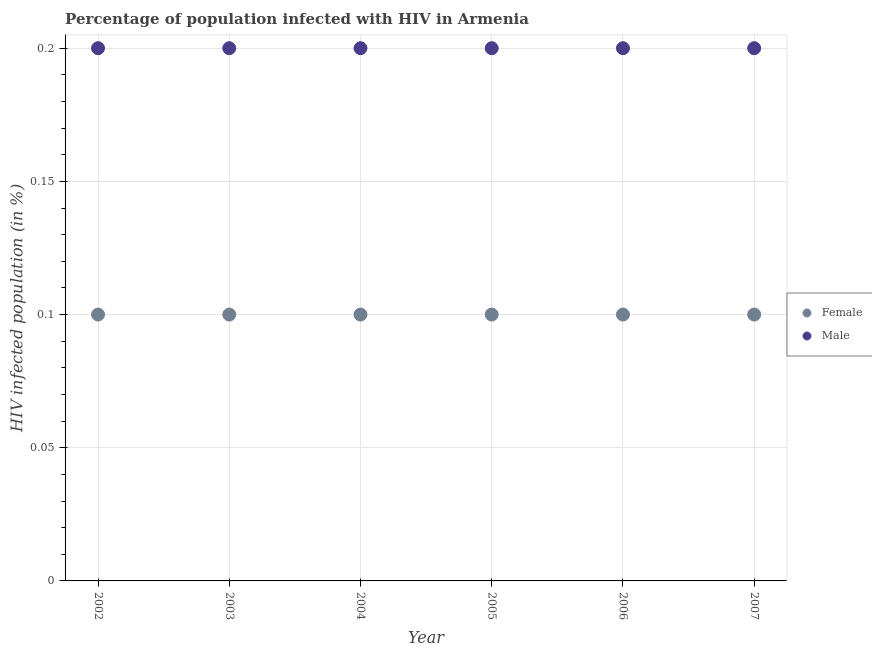How many different coloured dotlines are there?
Give a very brief answer. 2. Is the number of dotlines equal to the number of legend labels?
Keep it short and to the point. Yes. Across all years, what is the maximum percentage of males who are infected with hiv?
Keep it short and to the point. 0.2. What is the total percentage of females who are infected with hiv in the graph?
Offer a very short reply. 0.6. What is the average percentage of males who are infected with hiv per year?
Your answer should be very brief. 0.2. In how many years, is the percentage of males who are infected with hiv greater than 0.03 %?
Make the answer very short. 6. What is the ratio of the percentage of females who are infected with hiv in 2002 to that in 2004?
Ensure brevity in your answer.  1. Is the percentage of females who are infected with hiv in 2004 less than that in 2007?
Your answer should be compact. No. Is the difference between the percentage of males who are infected with hiv in 2005 and 2006 greater than the difference between the percentage of females who are infected with hiv in 2005 and 2006?
Your answer should be very brief. No. In how many years, is the percentage of females who are infected with hiv greater than the average percentage of females who are infected with hiv taken over all years?
Offer a terse response. 6. Is the sum of the percentage of females who are infected with hiv in 2005 and 2007 greater than the maximum percentage of males who are infected with hiv across all years?
Ensure brevity in your answer.  No. Does the percentage of females who are infected with hiv monotonically increase over the years?
Your answer should be compact. No. Is the percentage of males who are infected with hiv strictly greater than the percentage of females who are infected with hiv over the years?
Provide a short and direct response. Yes. Is the percentage of females who are infected with hiv strictly less than the percentage of males who are infected with hiv over the years?
Make the answer very short. Yes. How many dotlines are there?
Make the answer very short. 2. What is the difference between two consecutive major ticks on the Y-axis?
Make the answer very short. 0.05. Are the values on the major ticks of Y-axis written in scientific E-notation?
Offer a terse response. No. Does the graph contain grids?
Offer a terse response. Yes. How many legend labels are there?
Keep it short and to the point. 2. What is the title of the graph?
Keep it short and to the point. Percentage of population infected with HIV in Armenia. Does "Commercial service imports" appear as one of the legend labels in the graph?
Offer a terse response. No. What is the label or title of the Y-axis?
Your answer should be compact. HIV infected population (in %). What is the HIV infected population (in %) in Female in 2002?
Provide a succinct answer. 0.1. What is the HIV infected population (in %) in Male in 2003?
Your answer should be compact. 0.2. What is the HIV infected population (in %) of Male in 2005?
Your answer should be compact. 0.2. What is the HIV infected population (in %) in Male in 2006?
Your answer should be very brief. 0.2. What is the HIV infected population (in %) of Female in 2007?
Your answer should be very brief. 0.1. What is the HIV infected population (in %) of Male in 2007?
Your answer should be compact. 0.2. What is the total HIV infected population (in %) in Female in the graph?
Provide a short and direct response. 0.6. What is the total HIV infected population (in %) in Male in the graph?
Offer a very short reply. 1.2. What is the difference between the HIV infected population (in %) of Female in 2002 and that in 2005?
Your answer should be compact. 0. What is the difference between the HIV infected population (in %) in Female in 2002 and that in 2006?
Your answer should be compact. 0. What is the difference between the HIV infected population (in %) in Male in 2002 and that in 2006?
Your answer should be compact. 0. What is the difference between the HIV infected population (in %) in Female in 2002 and that in 2007?
Your answer should be compact. 0. What is the difference between the HIV infected population (in %) in Male in 2003 and that in 2004?
Offer a very short reply. 0. What is the difference between the HIV infected population (in %) in Female in 2003 and that in 2005?
Offer a very short reply. 0. What is the difference between the HIV infected population (in %) in Female in 2003 and that in 2007?
Ensure brevity in your answer.  0. What is the difference between the HIV infected population (in %) of Male in 2003 and that in 2007?
Ensure brevity in your answer.  0. What is the difference between the HIV infected population (in %) in Male in 2004 and that in 2005?
Offer a very short reply. 0. What is the difference between the HIV infected population (in %) in Female in 2005 and that in 2006?
Offer a terse response. 0. What is the difference between the HIV infected population (in %) in Male in 2005 and that in 2007?
Provide a short and direct response. 0. What is the difference between the HIV infected population (in %) in Male in 2006 and that in 2007?
Provide a succinct answer. 0. What is the difference between the HIV infected population (in %) in Female in 2002 and the HIV infected population (in %) in Male in 2003?
Your response must be concise. -0.1. What is the difference between the HIV infected population (in %) in Female in 2002 and the HIV infected population (in %) in Male in 2004?
Give a very brief answer. -0.1. What is the difference between the HIV infected population (in %) in Female in 2002 and the HIV infected population (in %) in Male in 2005?
Your response must be concise. -0.1. What is the difference between the HIV infected population (in %) in Female in 2002 and the HIV infected population (in %) in Male in 2007?
Ensure brevity in your answer.  -0.1. What is the difference between the HIV infected population (in %) of Female in 2003 and the HIV infected population (in %) of Male in 2006?
Make the answer very short. -0.1. What is the difference between the HIV infected population (in %) of Female in 2004 and the HIV infected population (in %) of Male in 2007?
Provide a succinct answer. -0.1. What is the difference between the HIV infected population (in %) of Female in 2005 and the HIV infected population (in %) of Male in 2006?
Your response must be concise. -0.1. What is the difference between the HIV infected population (in %) of Female in 2005 and the HIV infected population (in %) of Male in 2007?
Make the answer very short. -0.1. What is the average HIV infected population (in %) in Male per year?
Make the answer very short. 0.2. In the year 2003, what is the difference between the HIV infected population (in %) of Female and HIV infected population (in %) of Male?
Ensure brevity in your answer.  -0.1. In the year 2006, what is the difference between the HIV infected population (in %) of Female and HIV infected population (in %) of Male?
Offer a very short reply. -0.1. In the year 2007, what is the difference between the HIV infected population (in %) in Female and HIV infected population (in %) in Male?
Offer a very short reply. -0.1. What is the ratio of the HIV infected population (in %) of Female in 2002 to that in 2003?
Make the answer very short. 1. What is the ratio of the HIV infected population (in %) of Male in 2002 to that in 2003?
Your response must be concise. 1. What is the ratio of the HIV infected population (in %) of Male in 2002 to that in 2004?
Ensure brevity in your answer.  1. What is the ratio of the HIV infected population (in %) of Female in 2002 to that in 2006?
Make the answer very short. 1. What is the ratio of the HIV infected population (in %) in Female in 2003 to that in 2004?
Provide a succinct answer. 1. What is the ratio of the HIV infected population (in %) in Female in 2003 to that in 2005?
Offer a terse response. 1. What is the ratio of the HIV infected population (in %) of Female in 2003 to that in 2006?
Ensure brevity in your answer.  1. What is the ratio of the HIV infected population (in %) in Female in 2003 to that in 2007?
Provide a succinct answer. 1. What is the ratio of the HIV infected population (in %) in Male in 2003 to that in 2007?
Provide a short and direct response. 1. What is the ratio of the HIV infected population (in %) in Male in 2004 to that in 2005?
Provide a short and direct response. 1. What is the ratio of the HIV infected population (in %) in Male in 2004 to that in 2006?
Provide a succinct answer. 1. What is the ratio of the HIV infected population (in %) in Female in 2004 to that in 2007?
Provide a short and direct response. 1. What is the ratio of the HIV infected population (in %) in Male in 2004 to that in 2007?
Make the answer very short. 1. What is the ratio of the HIV infected population (in %) in Female in 2005 to that in 2006?
Provide a short and direct response. 1. What is the ratio of the HIV infected population (in %) in Male in 2005 to that in 2006?
Your answer should be very brief. 1. What is the ratio of the HIV infected population (in %) of Female in 2005 to that in 2007?
Give a very brief answer. 1. What is the ratio of the HIV infected population (in %) in Female in 2006 to that in 2007?
Ensure brevity in your answer.  1. What is the ratio of the HIV infected population (in %) of Male in 2006 to that in 2007?
Give a very brief answer. 1. What is the difference between the highest and the second highest HIV infected population (in %) of Female?
Make the answer very short. 0. 